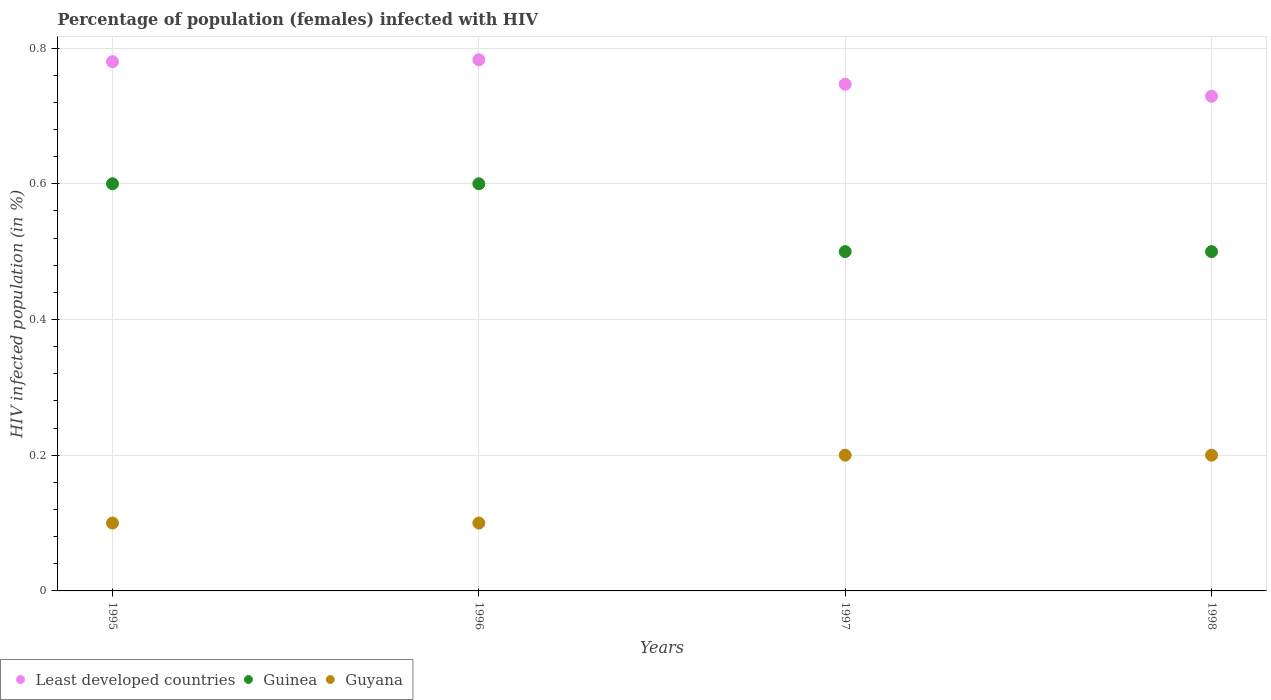How many different coloured dotlines are there?
Your answer should be compact. 3. What is the percentage of HIV infected female population in Guyana in 1995?
Provide a succinct answer. 0.1. Across all years, what is the maximum percentage of HIV infected female population in Guyana?
Keep it short and to the point. 0.2. Across all years, what is the minimum percentage of HIV infected female population in Least developed countries?
Offer a terse response. 0.73. What is the difference between the percentage of HIV infected female population in Guinea in 1995 and that in 1997?
Ensure brevity in your answer.  0.1. What is the difference between the percentage of HIV infected female population in Least developed countries in 1995 and the percentage of HIV infected female population in Guyana in 1997?
Offer a very short reply. 0.58. What is the average percentage of HIV infected female population in Least developed countries per year?
Your answer should be very brief. 0.76. In the year 1996, what is the difference between the percentage of HIV infected female population in Guyana and percentage of HIV infected female population in Least developed countries?
Make the answer very short. -0.68. In how many years, is the percentage of HIV infected female population in Guyana greater than 0.68 %?
Provide a short and direct response. 0. Is the sum of the percentage of HIV infected female population in Least developed countries in 1995 and 1997 greater than the maximum percentage of HIV infected female population in Guinea across all years?
Your response must be concise. Yes. Is it the case that in every year, the sum of the percentage of HIV infected female population in Least developed countries and percentage of HIV infected female population in Guinea  is greater than the percentage of HIV infected female population in Guyana?
Give a very brief answer. Yes. How many years are there in the graph?
Your answer should be compact. 4. What is the difference between two consecutive major ticks on the Y-axis?
Your answer should be very brief. 0.2. Are the values on the major ticks of Y-axis written in scientific E-notation?
Ensure brevity in your answer.  No. How many legend labels are there?
Ensure brevity in your answer.  3. How are the legend labels stacked?
Make the answer very short. Horizontal. What is the title of the graph?
Your answer should be very brief. Percentage of population (females) infected with HIV. Does "Korea (Democratic)" appear as one of the legend labels in the graph?
Provide a succinct answer. No. What is the label or title of the X-axis?
Provide a short and direct response. Years. What is the label or title of the Y-axis?
Provide a succinct answer. HIV infected population (in %). What is the HIV infected population (in %) of Least developed countries in 1995?
Provide a succinct answer. 0.78. What is the HIV infected population (in %) in Guyana in 1995?
Your answer should be compact. 0.1. What is the HIV infected population (in %) of Least developed countries in 1996?
Give a very brief answer. 0.78. What is the HIV infected population (in %) of Least developed countries in 1997?
Offer a very short reply. 0.75. What is the HIV infected population (in %) of Guinea in 1997?
Offer a terse response. 0.5. What is the HIV infected population (in %) in Least developed countries in 1998?
Ensure brevity in your answer.  0.73. What is the HIV infected population (in %) of Guyana in 1998?
Offer a terse response. 0.2. Across all years, what is the maximum HIV infected population (in %) of Least developed countries?
Provide a short and direct response. 0.78. Across all years, what is the minimum HIV infected population (in %) in Least developed countries?
Keep it short and to the point. 0.73. Across all years, what is the minimum HIV infected population (in %) of Guyana?
Your answer should be compact. 0.1. What is the total HIV infected population (in %) in Least developed countries in the graph?
Offer a very short reply. 3.04. What is the total HIV infected population (in %) in Guyana in the graph?
Your response must be concise. 0.6. What is the difference between the HIV infected population (in %) of Least developed countries in 1995 and that in 1996?
Give a very brief answer. -0. What is the difference between the HIV infected population (in %) in Guyana in 1995 and that in 1996?
Provide a succinct answer. 0. What is the difference between the HIV infected population (in %) in Least developed countries in 1995 and that in 1997?
Your response must be concise. 0.03. What is the difference between the HIV infected population (in %) in Least developed countries in 1995 and that in 1998?
Your response must be concise. 0.05. What is the difference between the HIV infected population (in %) in Guyana in 1995 and that in 1998?
Ensure brevity in your answer.  -0.1. What is the difference between the HIV infected population (in %) of Least developed countries in 1996 and that in 1997?
Offer a terse response. 0.04. What is the difference between the HIV infected population (in %) in Guinea in 1996 and that in 1997?
Provide a succinct answer. 0.1. What is the difference between the HIV infected population (in %) of Least developed countries in 1996 and that in 1998?
Your answer should be very brief. 0.05. What is the difference between the HIV infected population (in %) of Guyana in 1996 and that in 1998?
Keep it short and to the point. -0.1. What is the difference between the HIV infected population (in %) in Least developed countries in 1997 and that in 1998?
Offer a very short reply. 0.02. What is the difference between the HIV infected population (in %) in Guyana in 1997 and that in 1998?
Ensure brevity in your answer.  0. What is the difference between the HIV infected population (in %) of Least developed countries in 1995 and the HIV infected population (in %) of Guinea in 1996?
Offer a very short reply. 0.18. What is the difference between the HIV infected population (in %) in Least developed countries in 1995 and the HIV infected population (in %) in Guyana in 1996?
Provide a short and direct response. 0.68. What is the difference between the HIV infected population (in %) of Least developed countries in 1995 and the HIV infected population (in %) of Guinea in 1997?
Make the answer very short. 0.28. What is the difference between the HIV infected population (in %) of Least developed countries in 1995 and the HIV infected population (in %) of Guyana in 1997?
Provide a succinct answer. 0.58. What is the difference between the HIV infected population (in %) of Least developed countries in 1995 and the HIV infected population (in %) of Guinea in 1998?
Provide a short and direct response. 0.28. What is the difference between the HIV infected population (in %) of Least developed countries in 1995 and the HIV infected population (in %) of Guyana in 1998?
Ensure brevity in your answer.  0.58. What is the difference between the HIV infected population (in %) in Least developed countries in 1996 and the HIV infected population (in %) in Guinea in 1997?
Your response must be concise. 0.28. What is the difference between the HIV infected population (in %) of Least developed countries in 1996 and the HIV infected population (in %) of Guyana in 1997?
Your answer should be very brief. 0.58. What is the difference between the HIV infected population (in %) in Least developed countries in 1996 and the HIV infected population (in %) in Guinea in 1998?
Provide a short and direct response. 0.28. What is the difference between the HIV infected population (in %) of Least developed countries in 1996 and the HIV infected population (in %) of Guyana in 1998?
Provide a short and direct response. 0.58. What is the difference between the HIV infected population (in %) of Least developed countries in 1997 and the HIV infected population (in %) of Guinea in 1998?
Give a very brief answer. 0.25. What is the difference between the HIV infected population (in %) of Least developed countries in 1997 and the HIV infected population (in %) of Guyana in 1998?
Offer a very short reply. 0.55. What is the difference between the HIV infected population (in %) of Guinea in 1997 and the HIV infected population (in %) of Guyana in 1998?
Offer a very short reply. 0.3. What is the average HIV infected population (in %) in Least developed countries per year?
Provide a succinct answer. 0.76. What is the average HIV infected population (in %) in Guinea per year?
Your answer should be very brief. 0.55. What is the average HIV infected population (in %) of Guyana per year?
Offer a very short reply. 0.15. In the year 1995, what is the difference between the HIV infected population (in %) in Least developed countries and HIV infected population (in %) in Guinea?
Provide a short and direct response. 0.18. In the year 1995, what is the difference between the HIV infected population (in %) in Least developed countries and HIV infected population (in %) in Guyana?
Your answer should be compact. 0.68. In the year 1996, what is the difference between the HIV infected population (in %) in Least developed countries and HIV infected population (in %) in Guinea?
Your response must be concise. 0.18. In the year 1996, what is the difference between the HIV infected population (in %) of Least developed countries and HIV infected population (in %) of Guyana?
Make the answer very short. 0.68. In the year 1997, what is the difference between the HIV infected population (in %) in Least developed countries and HIV infected population (in %) in Guinea?
Provide a succinct answer. 0.25. In the year 1997, what is the difference between the HIV infected population (in %) of Least developed countries and HIV infected population (in %) of Guyana?
Provide a succinct answer. 0.55. In the year 1998, what is the difference between the HIV infected population (in %) in Least developed countries and HIV infected population (in %) in Guinea?
Offer a terse response. 0.23. In the year 1998, what is the difference between the HIV infected population (in %) of Least developed countries and HIV infected population (in %) of Guyana?
Your answer should be compact. 0.53. In the year 1998, what is the difference between the HIV infected population (in %) in Guinea and HIV infected population (in %) in Guyana?
Offer a terse response. 0.3. What is the ratio of the HIV infected population (in %) of Least developed countries in 1995 to that in 1997?
Offer a very short reply. 1.04. What is the ratio of the HIV infected population (in %) of Guyana in 1995 to that in 1997?
Provide a succinct answer. 0.5. What is the ratio of the HIV infected population (in %) of Least developed countries in 1995 to that in 1998?
Offer a terse response. 1.07. What is the ratio of the HIV infected population (in %) of Guinea in 1995 to that in 1998?
Ensure brevity in your answer.  1.2. What is the ratio of the HIV infected population (in %) in Least developed countries in 1996 to that in 1997?
Keep it short and to the point. 1.05. What is the ratio of the HIV infected population (in %) of Least developed countries in 1996 to that in 1998?
Keep it short and to the point. 1.07. What is the ratio of the HIV infected population (in %) of Guinea in 1996 to that in 1998?
Offer a very short reply. 1.2. What is the ratio of the HIV infected population (in %) in Least developed countries in 1997 to that in 1998?
Give a very brief answer. 1.02. What is the ratio of the HIV infected population (in %) of Guinea in 1997 to that in 1998?
Give a very brief answer. 1. What is the ratio of the HIV infected population (in %) in Guyana in 1997 to that in 1998?
Your response must be concise. 1. What is the difference between the highest and the second highest HIV infected population (in %) of Least developed countries?
Your response must be concise. 0. What is the difference between the highest and the lowest HIV infected population (in %) in Least developed countries?
Your answer should be very brief. 0.05. What is the difference between the highest and the lowest HIV infected population (in %) in Guinea?
Your response must be concise. 0.1. What is the difference between the highest and the lowest HIV infected population (in %) in Guyana?
Your response must be concise. 0.1. 